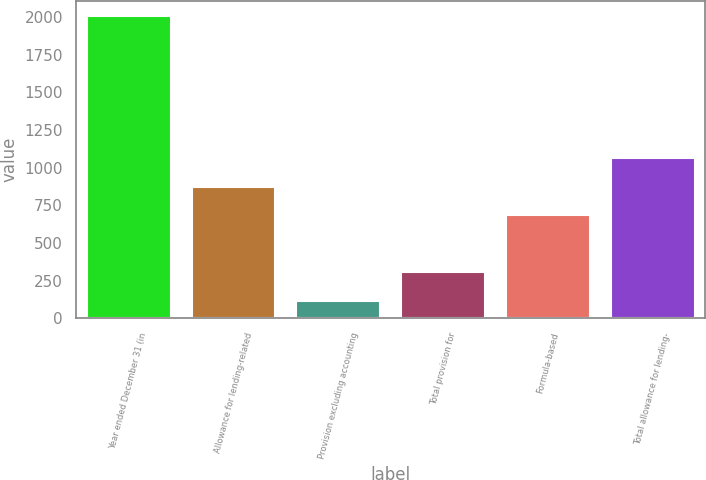Convert chart to OTSL. <chart><loc_0><loc_0><loc_500><loc_500><bar_chart><fcel>Year ended December 31 (in<fcel>Allowance for lending-related<fcel>Provision excluding accounting<fcel>Total provision for<fcel>Formula-based<fcel>Total allowance for lending-<nl><fcel>2006<fcel>872.6<fcel>117<fcel>305.9<fcel>683.7<fcel>1061.5<nl></chart> 